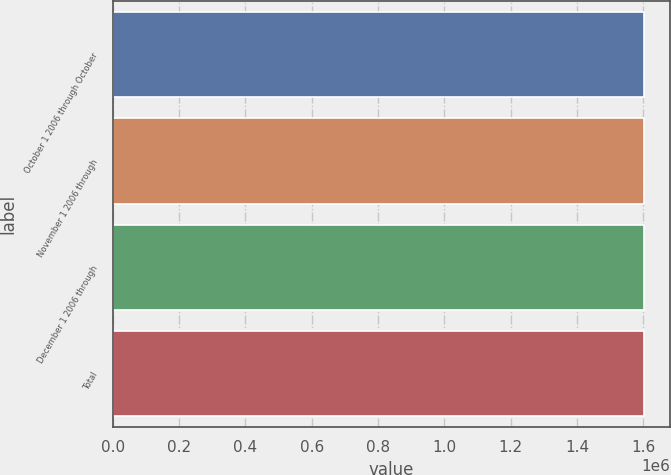<chart> <loc_0><loc_0><loc_500><loc_500><bar_chart><fcel>October 1 2006 through October<fcel>November 1 2006 through<fcel>December 1 2006 through<fcel>Total<nl><fcel>1.60058e+06<fcel>1.60058e+06<fcel>1.60058e+06<fcel>1.60058e+06<nl></chart> 